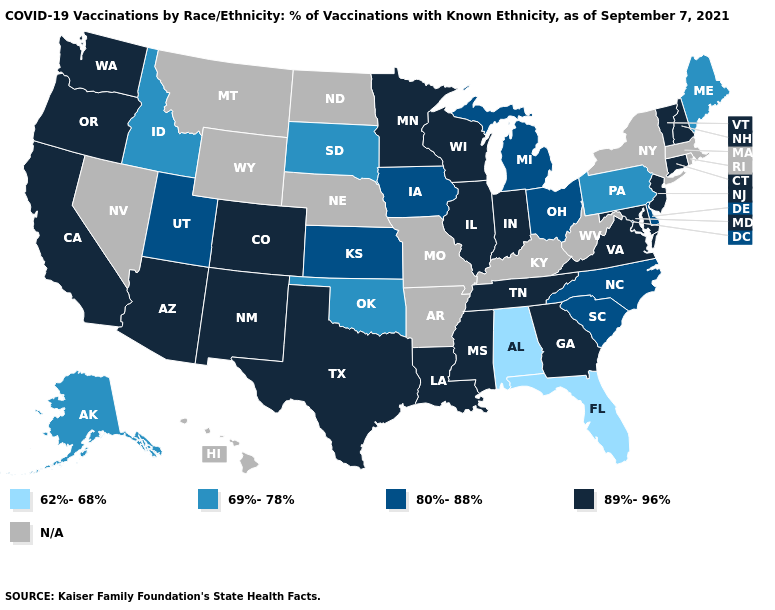Does Maine have the lowest value in the Northeast?
Quick response, please. Yes. Does the first symbol in the legend represent the smallest category?
Be succinct. Yes. What is the value of Virginia?
Give a very brief answer. 89%-96%. Name the states that have a value in the range 89%-96%?
Quick response, please. Arizona, California, Colorado, Connecticut, Georgia, Illinois, Indiana, Louisiana, Maryland, Minnesota, Mississippi, New Hampshire, New Jersey, New Mexico, Oregon, Tennessee, Texas, Vermont, Virginia, Washington, Wisconsin. What is the value of Maryland?
Answer briefly. 89%-96%. Name the states that have a value in the range 80%-88%?
Keep it brief. Delaware, Iowa, Kansas, Michigan, North Carolina, Ohio, South Carolina, Utah. Name the states that have a value in the range 69%-78%?
Quick response, please. Alaska, Idaho, Maine, Oklahoma, Pennsylvania, South Dakota. Name the states that have a value in the range 80%-88%?
Give a very brief answer. Delaware, Iowa, Kansas, Michigan, North Carolina, Ohio, South Carolina, Utah. What is the value of Pennsylvania?
Quick response, please. 69%-78%. What is the highest value in the USA?
Give a very brief answer. 89%-96%. Which states have the lowest value in the USA?
Answer briefly. Alabama, Florida. What is the lowest value in the MidWest?
Keep it brief. 69%-78%. 